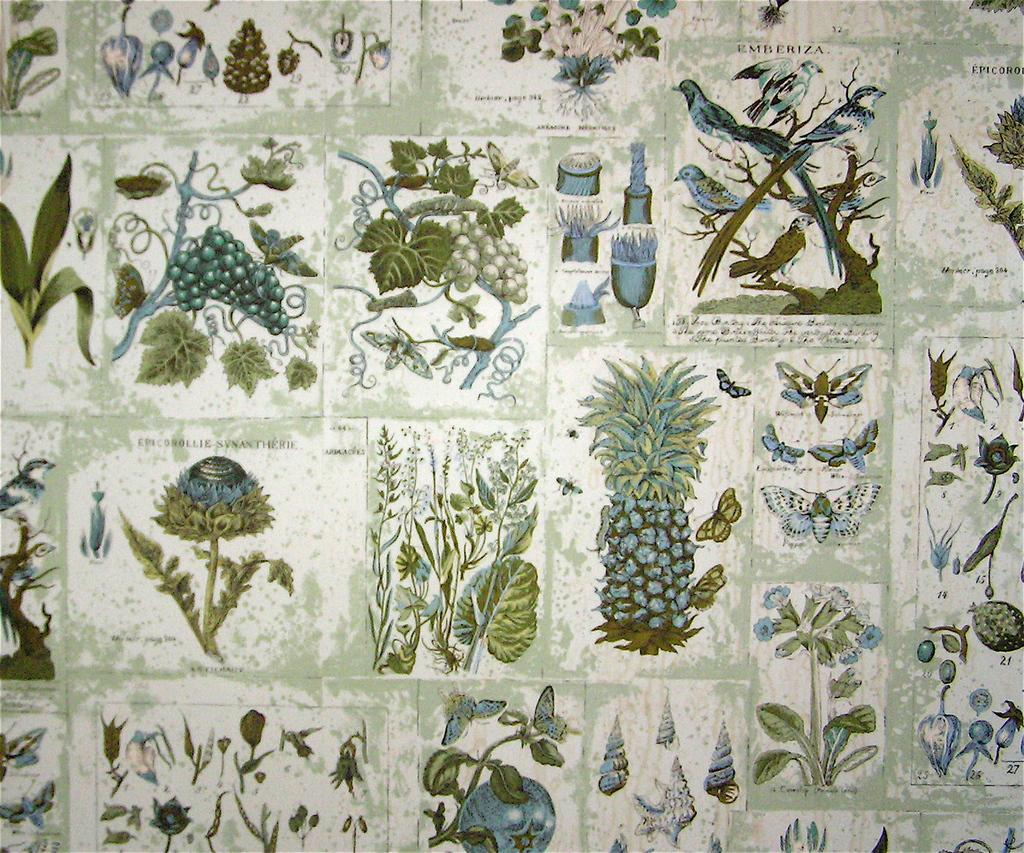What is featured on the posters in the image? The posters contain green plants, a pineapple, butterflies, birds, grapes, and flowers. Can you describe the plants depicted on the posters? The plants on the posters are green. What other living creatures are present on the posters? Butterflies and birds are also depicted on the posters. What type of fruit is shown on the posters? Grapes are shown on the posters. What non-fruit plant elements are depicted on the posters? Flowers are depicted on the posters. What type of crate is used to store the ducks in the image? There are no ducks or crates present in the image. What treatment is being administered to the flowers on the posters? There is no treatment being administered to the flowers on the posters; they are simply depicted as part of the poster design. 